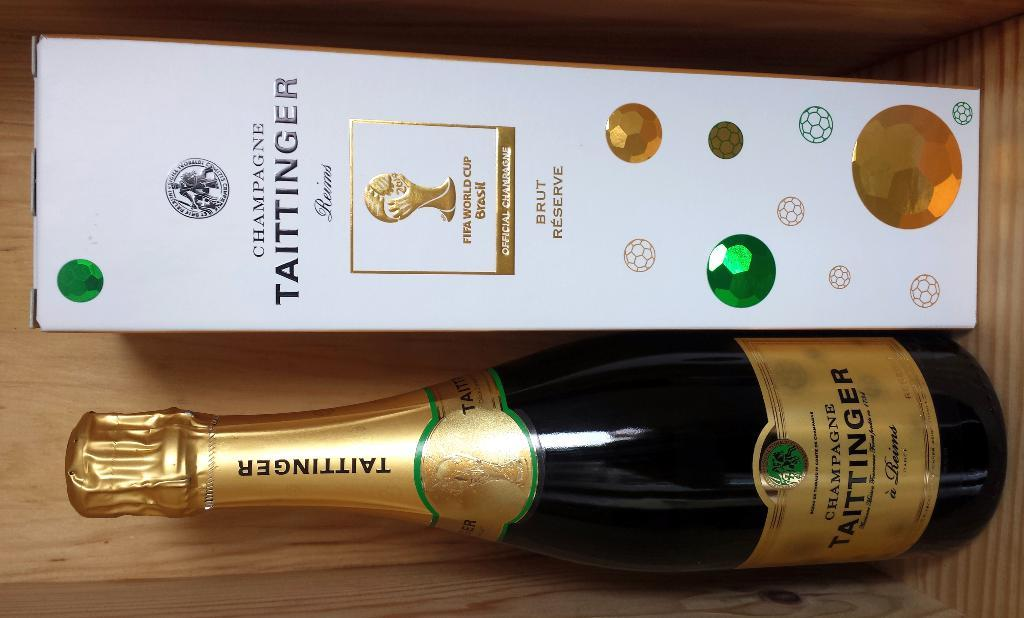Provide a one-sentence caption for the provided image. A wine bottle called TAITTINGER with a white box next to it. 